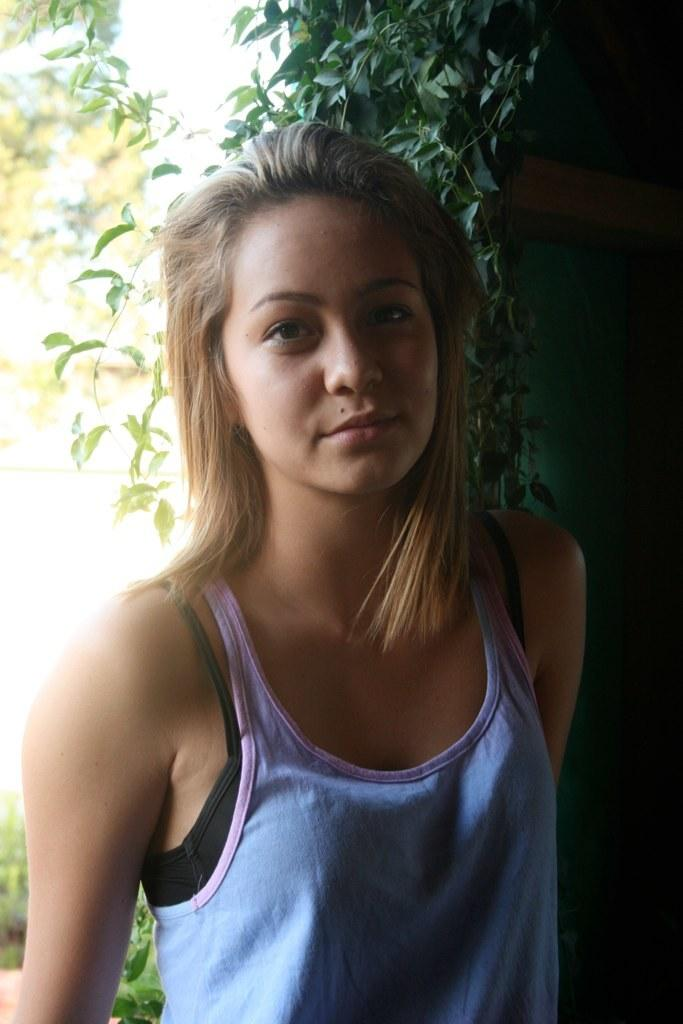What is the main subject of the image? There is a woman standing in the image. What can be seen in the background of the image? There are green leaves visible in the background of the image. What type of chalk is the woman using to draw on the ground in the image? There is no chalk or drawing activity present in the image. What kind of produce is the woman holding in the image? There is no produce visible in the image; the woman is not holding anything. 